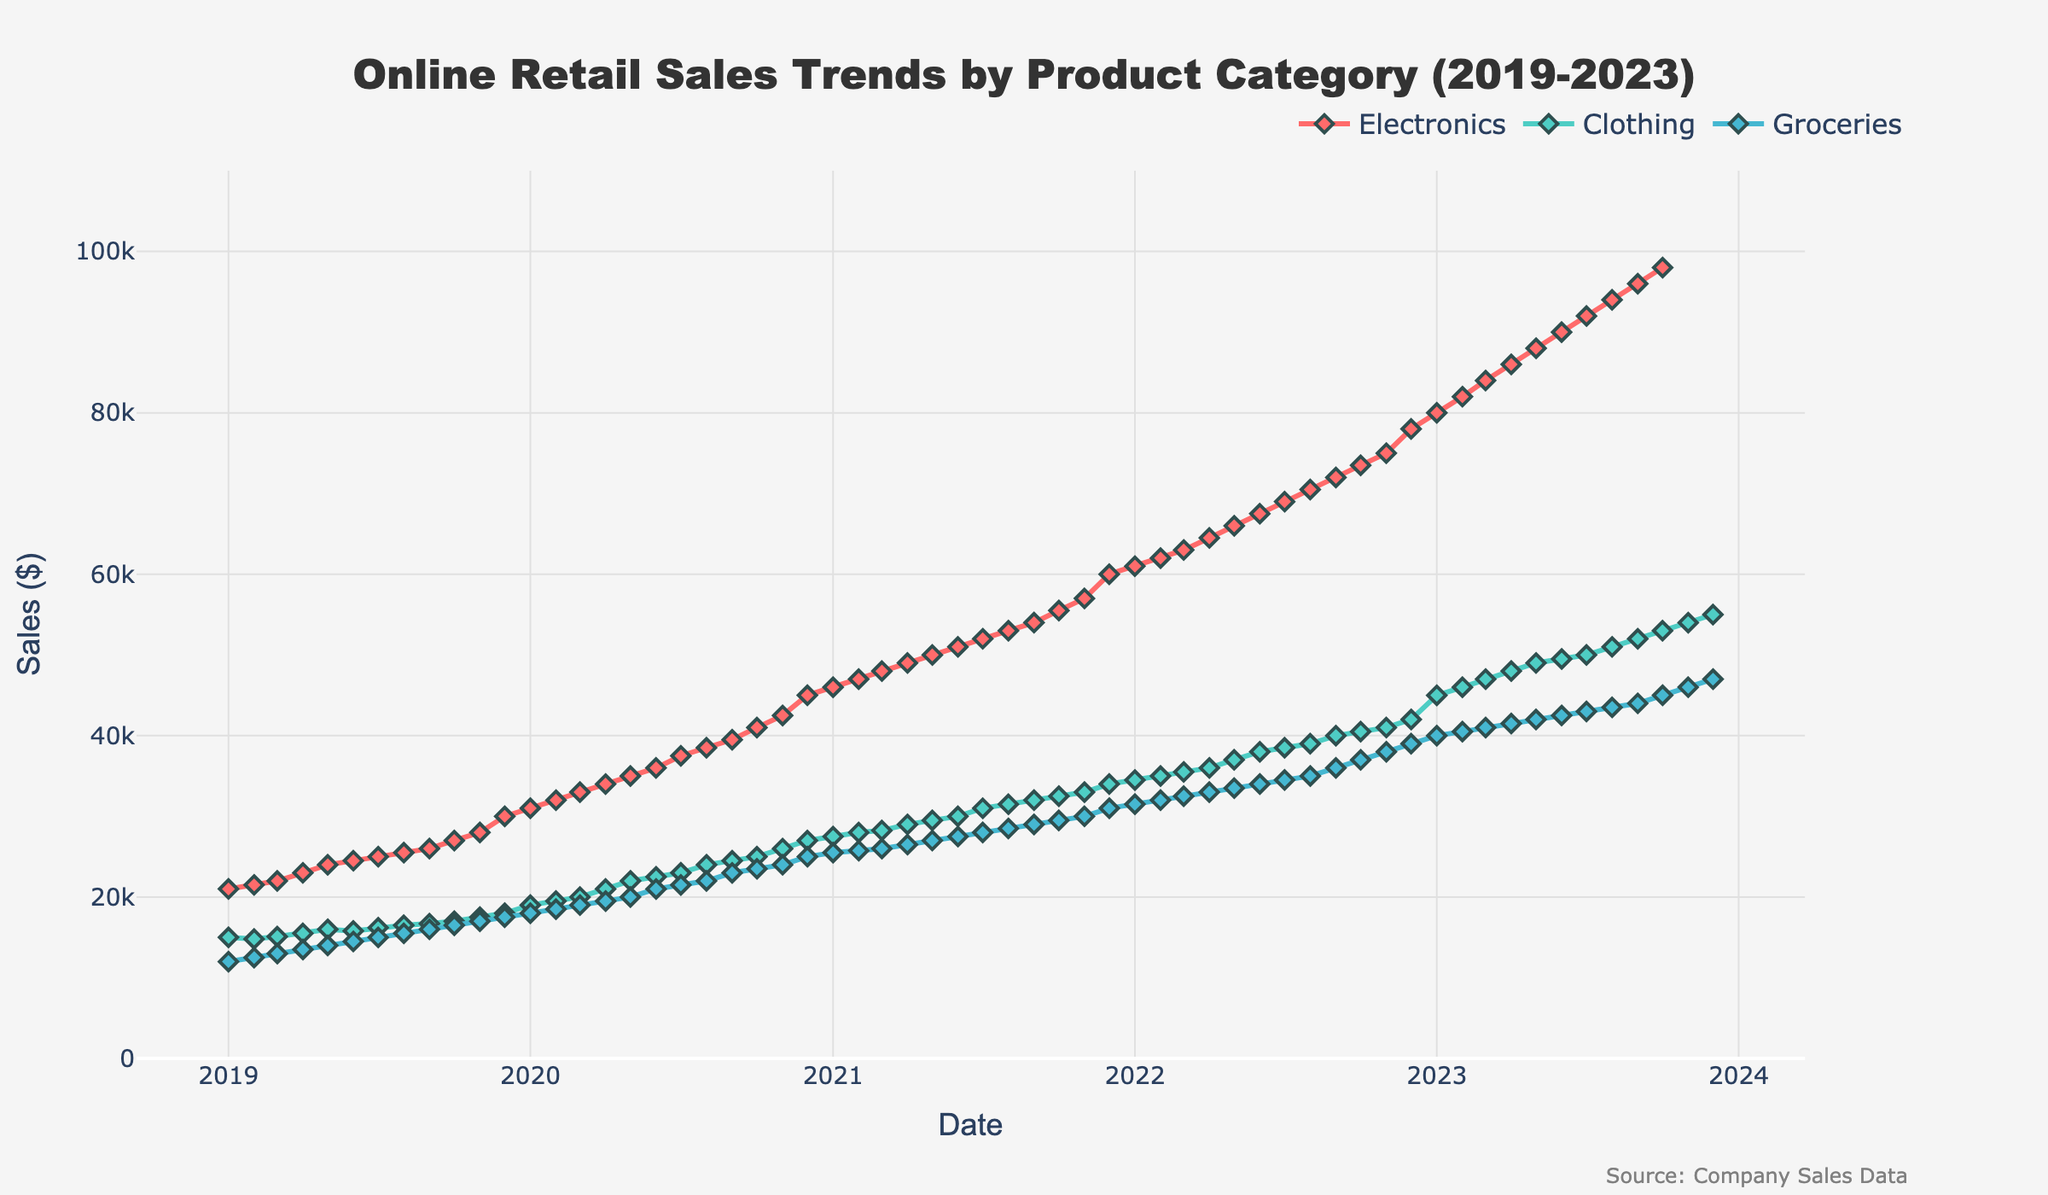What is the title of the plot? The title can be found at the top of the plot. It reads "Online Retail Sales Trends by Product Category (2019-2023)"
Answer: Online Retail Sales Trends by Product Category (2019-2023) What is the highest sales value for Electronics over the period? To find the highest sales value for Electronics, look for the peak point on the time series line corresponding to Electronics. The value reaches its maximum at the end of the plot with sales of $98,000.
Answer: $98,000 Which product category has the largest increase in sales from 2019 to 2023? Observe the initial and final sales values for each product category and calculate the difference. Electronics increased from $21,000 to $98,000, Clothing from $15,000 to $55,000, and Groceries from $12,000 to $47,000. Electronics has the largest increase.
Answer: Electronics What month and year did Clothing reach sales of $30,000 for the first time? Track the line representing Clothing and find when it crosses the $30,000 mark. Clothing first reached $30,000 in June 2021.
Answer: June 2021 Compare the sales trends of Electronics and Groceries in 2020. Did Electronics have consistently higher sales than Groceries every month? Check the sales values of Electronics and Groceries month by month in 2020. Electronics values range from $31,000 to $45,000, and Groceries range from $18,000 to $25,000, confirming that Electronics always had higher sales.
Answer: Yes Did any of the product categories show a decrease in sales during any period from 2019 to 2023? Analyze each product category line for any downward trends. None of the product categories show a decrease; all lines consistently rise.
Answer: No When was the largest month-to-month increase for Electronics observed, and what was the increase? Identify the largest vertical jump in the Electronics line. The largest increase was between Nov 2022 ($75,000) to Dec 2022 ($78,000), which is an increase of $3,000.
Answer: Nov 2022 to Dec 2022, $3,000 What were the sales values for Groceries in January 2022? Find the data point for Groceries in January 2022. The value is $31,500.
Answer: $31,500 On average, by how much did Clothing sales increase each year from 2019 to 2023? Calculate the annual increase in sales by dividing the total increase by the number of years. The increase from $15,000 to $55,000 over 4 years is $40,000. Dividing $40,000 by 4 gives an average rise of $10,000 per year.
Answer: $10,000 per year Which month in any year has the highest sales figures for all categories combined? Sum up the sales for each month across all categories and identify the highest. December 2023 has $98,000 (Electronics) + $55,000 (Clothing) + $47,000 (Groceries) = $200,000, the highest combined sales.
Answer: December 2023 